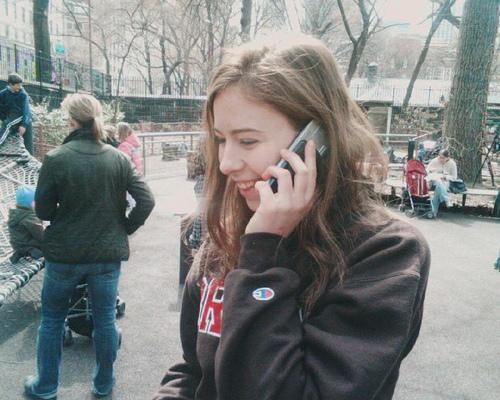What brand does the logo on the girl's sleeve represent?
Quick response, please. Champion. What color are the girls lips?
Write a very short answer. Pink. What this lady doing behind this girl?
Give a very brief answer. Standing. 